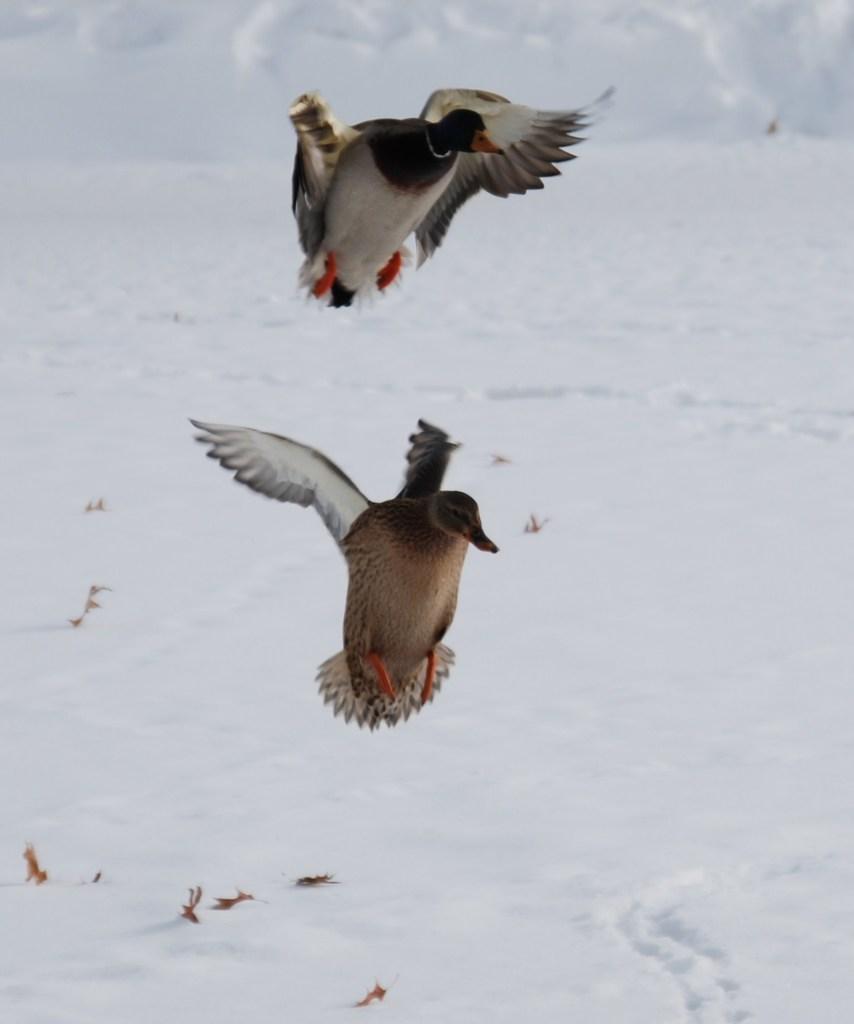Describe this image in one or two sentences. In this image I can see two birds and snow. This image is taken may be during a day. 